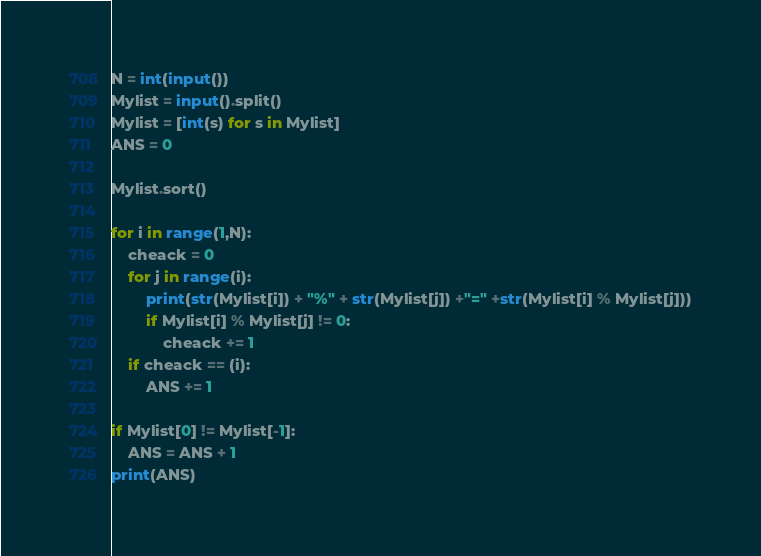<code> <loc_0><loc_0><loc_500><loc_500><_Python_>N = int(input())
Mylist = input().split()
Mylist = [int(s) for s in Mylist]
ANS = 0

Mylist.sort()

for i in range(1,N):
    cheack = 0
    for j in range(i):
        print(str(Mylist[i]) + "%" + str(Mylist[j]) +"=" +str(Mylist[i] % Mylist[j]))
        if Mylist[i] % Mylist[j] != 0:
            cheack += 1
    if cheack == (i):
        ANS += 1

if Mylist[0] != Mylist[-1]:
    ANS = ANS + 1
print(ANS)
</code> 